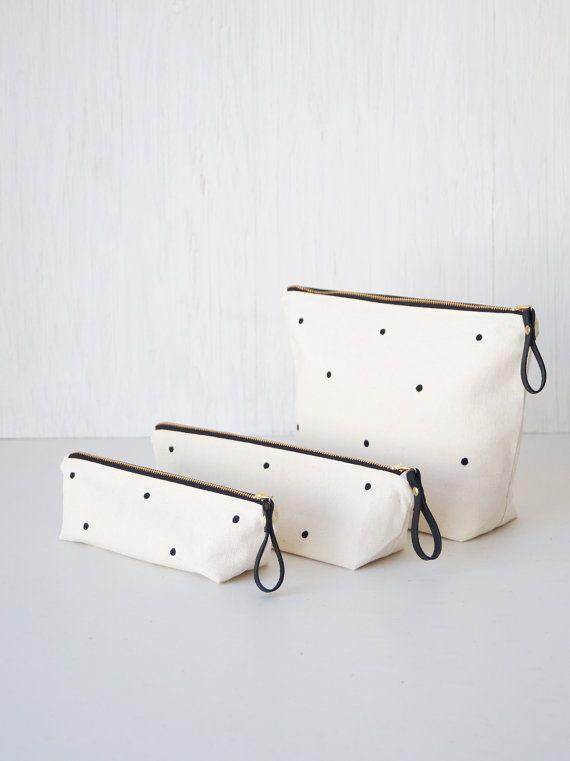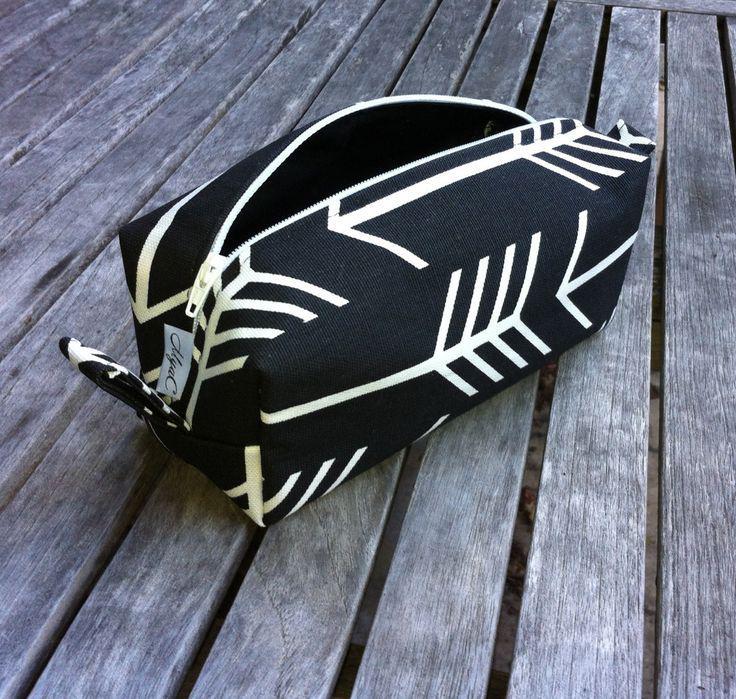The first image is the image on the left, the second image is the image on the right. Examine the images to the left and right. Is the description "One image shows a black-and-white pencil case made of patterned fabric, and the other shows a case with a phrase across the front." accurate? Answer yes or no. No. The first image is the image on the left, the second image is the image on the right. Analyze the images presented: Is the assertion "There are exactly two pencil bags, and there are pencils and/or pens sticking out of the left one." valid? Answer yes or no. No. 